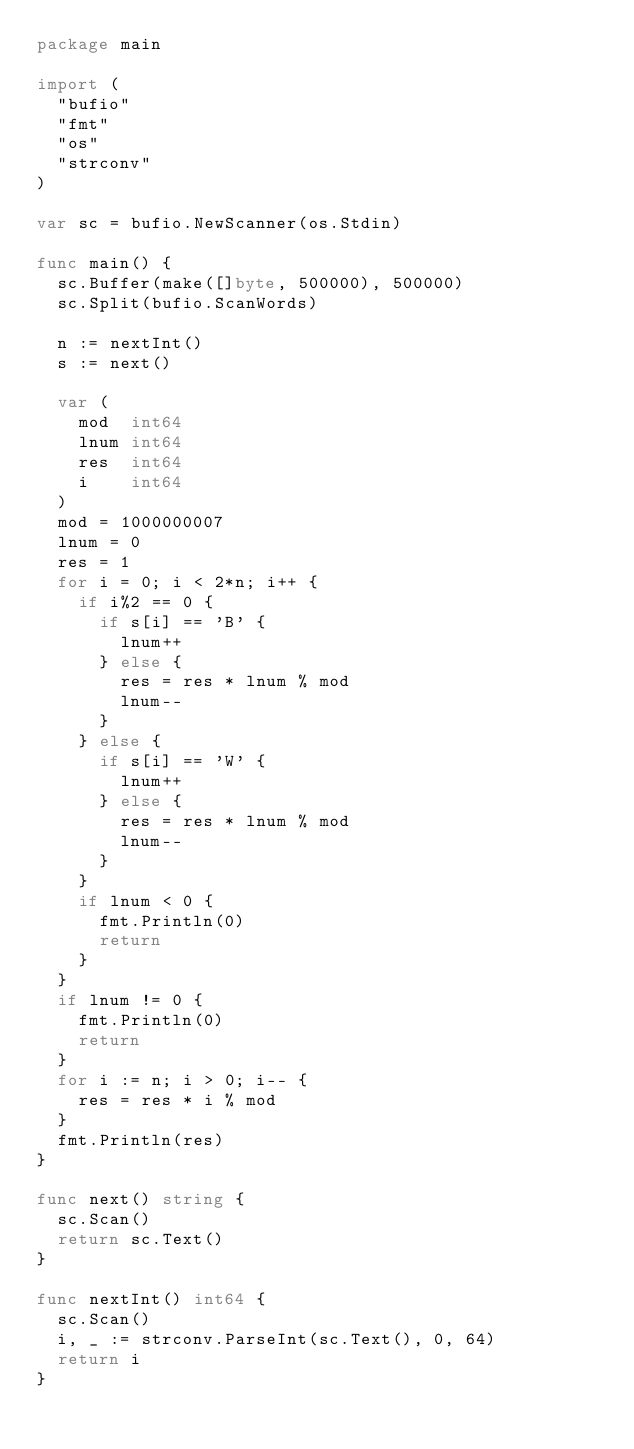Convert code to text. <code><loc_0><loc_0><loc_500><loc_500><_Go_>package main

import (
	"bufio"
	"fmt"
	"os"
	"strconv"
)

var sc = bufio.NewScanner(os.Stdin)

func main() {
	sc.Buffer(make([]byte, 500000), 500000)
	sc.Split(bufio.ScanWords)

	n := nextInt()
	s := next()

	var (
		mod  int64
		lnum int64
		res  int64
		i    int64
	)
	mod = 1000000007
	lnum = 0
	res = 1
	for i = 0; i < 2*n; i++ {
		if i%2 == 0 {
			if s[i] == 'B' {
				lnum++
			} else {
				res = res * lnum % mod
				lnum--
			}
		} else {
			if s[i] == 'W' {
				lnum++
			} else {
				res = res * lnum % mod
				lnum--
			}
		}
		if lnum < 0 {
			fmt.Println(0)
			return
		}
	}
	if lnum != 0 {
		fmt.Println(0)
		return
	}
	for i := n; i > 0; i-- {
		res = res * i % mod
	}
	fmt.Println(res)
}

func next() string {
	sc.Scan()
	return sc.Text()
}

func nextInt() int64 {
	sc.Scan()
	i, _ := strconv.ParseInt(sc.Text(), 0, 64)
	return i
}
</code> 